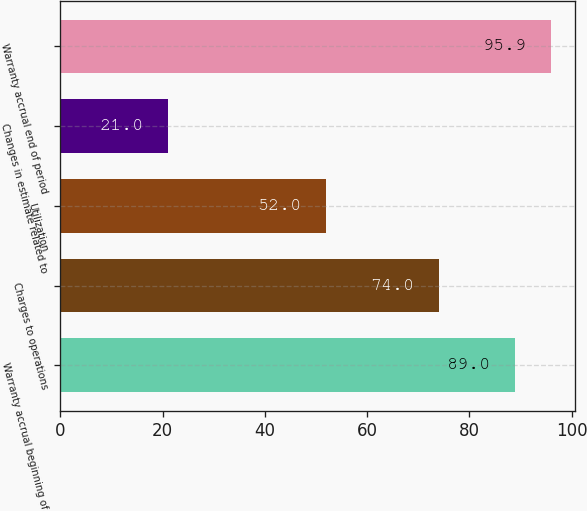<chart> <loc_0><loc_0><loc_500><loc_500><bar_chart><fcel>Warranty accrual beginning of<fcel>Charges to operations<fcel>Utilization<fcel>Changes in estimate related to<fcel>Warranty accrual end of period<nl><fcel>89<fcel>74<fcel>52<fcel>21<fcel>95.9<nl></chart> 